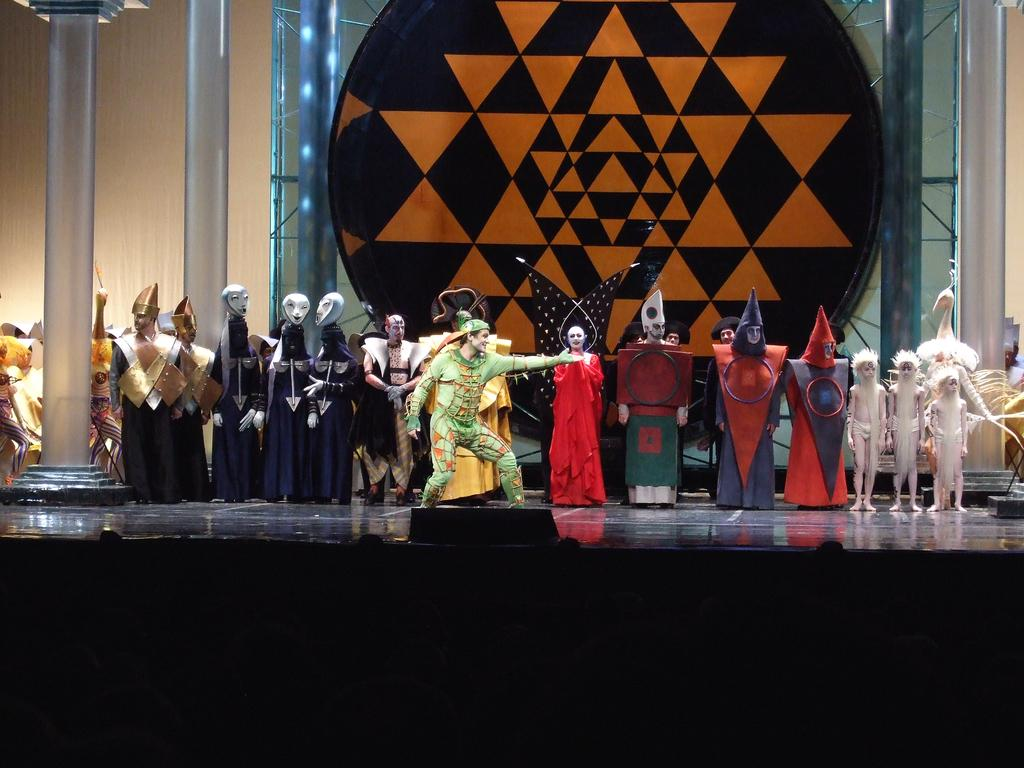What is the main subject of the image? The main subject of the image is a man. What is the man doing in the image? The man is performing different actions in the image. What is the man wearing in the image? The man is wearing a green dress in the image. What can be seen behind the man in the image? There are people in the shape of ghosts behind the man in the image. What type of board is the man using to perform his actions in the image? There is no board present in the image; the man is performing actions without any visible board. 